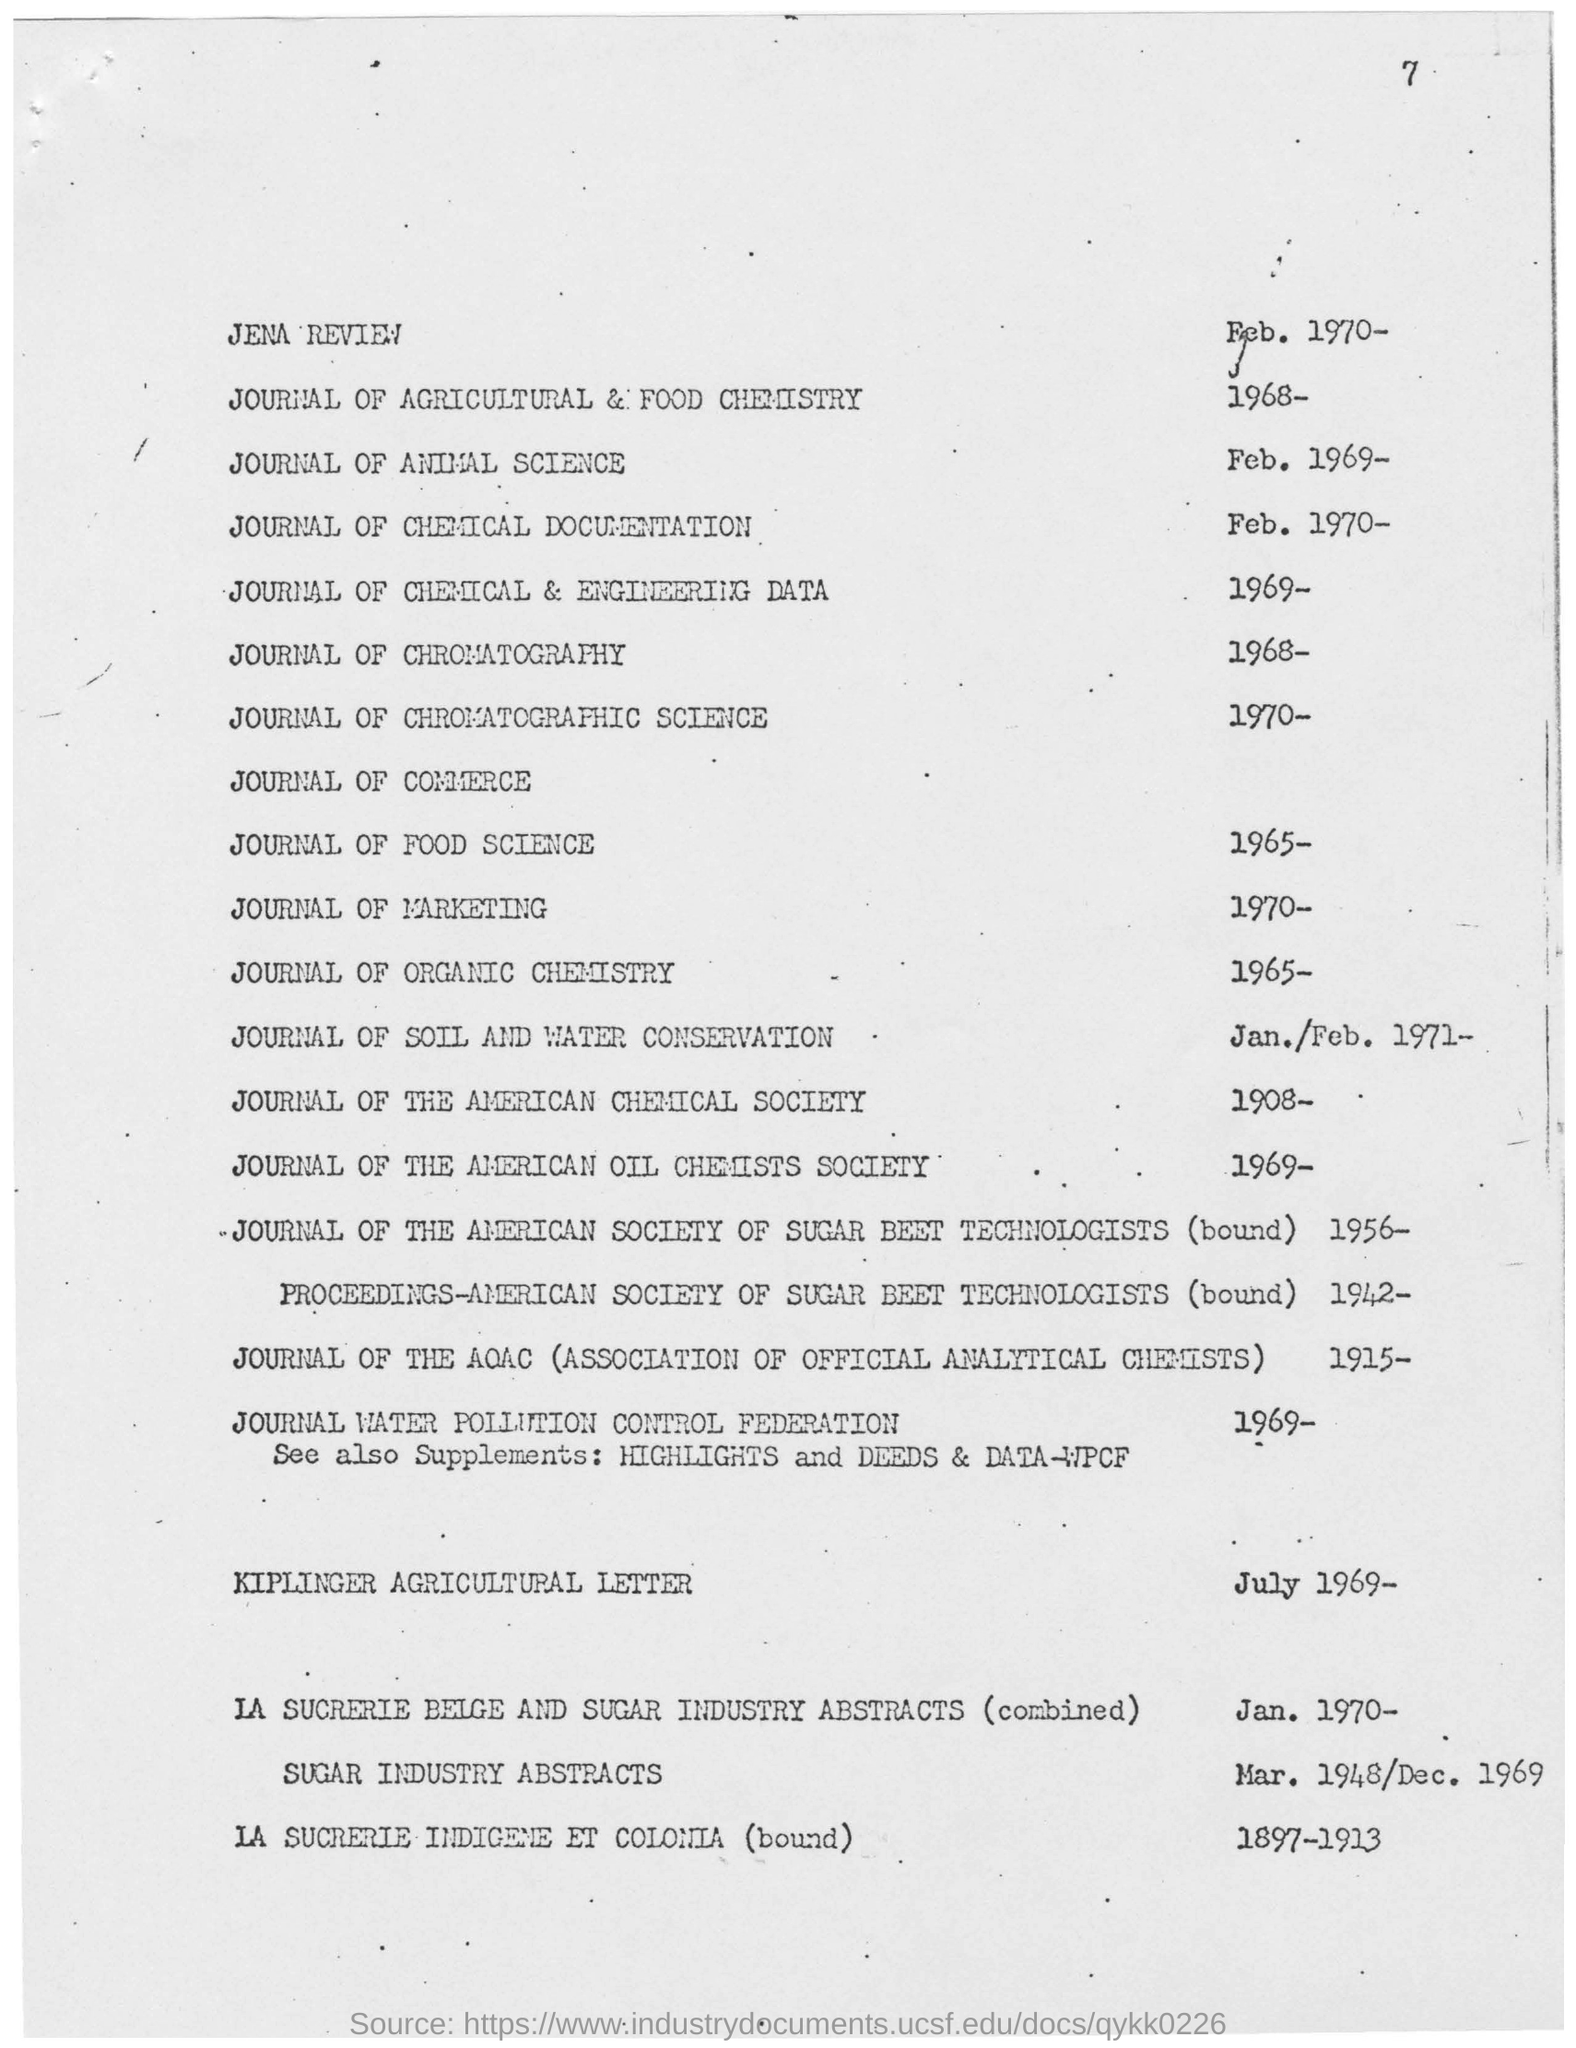Draw attention to some important aspects in this diagram. The Journal of Marketing is published from 1970 up to the present. The fourth journal listed is called "Journal of Chemical & Engineering Data. The Kiplinger Agricultural Letter was dated July 1969. 